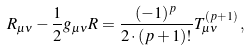<formula> <loc_0><loc_0><loc_500><loc_500>R _ { \mu \nu } - { \frac { 1 } { 2 } } g _ { \mu \nu } R = { \frac { ( - 1 ) ^ { p } } { 2 \cdot ( p + 1 ) ! } } T ^ { ( p + 1 ) } _ { \mu \nu } \, ,</formula> 